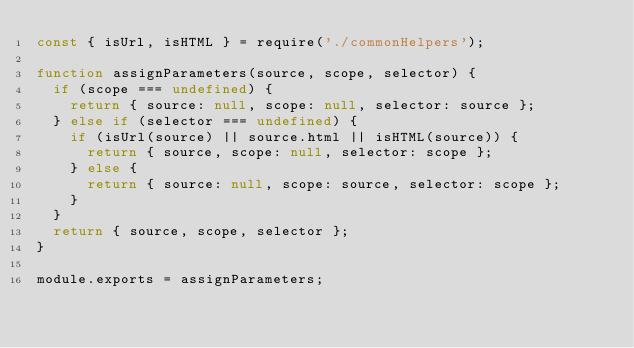Convert code to text. <code><loc_0><loc_0><loc_500><loc_500><_JavaScript_>const { isUrl, isHTML } = require('./commonHelpers');

function assignParameters(source, scope, selector) {
  if (scope === undefined) {
    return { source: null, scope: null, selector: source };
  } else if (selector === undefined) {
    if (isUrl(source) || source.html || isHTML(source)) {
      return { source, scope: null, selector: scope };
    } else {
      return { source: null, scope: source, selector: scope };
    }
  }
  return { source, scope, selector };
}

module.exports = assignParameters;</code> 